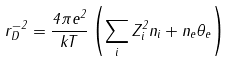<formula> <loc_0><loc_0><loc_500><loc_500>r _ { D } ^ { - 2 } = \frac { 4 \pi e ^ { 2 } } { k T } \left ( \sum _ { i } Z _ { i } ^ { 2 } n _ { i } + n _ { e } \theta _ { e } \right )</formula> 